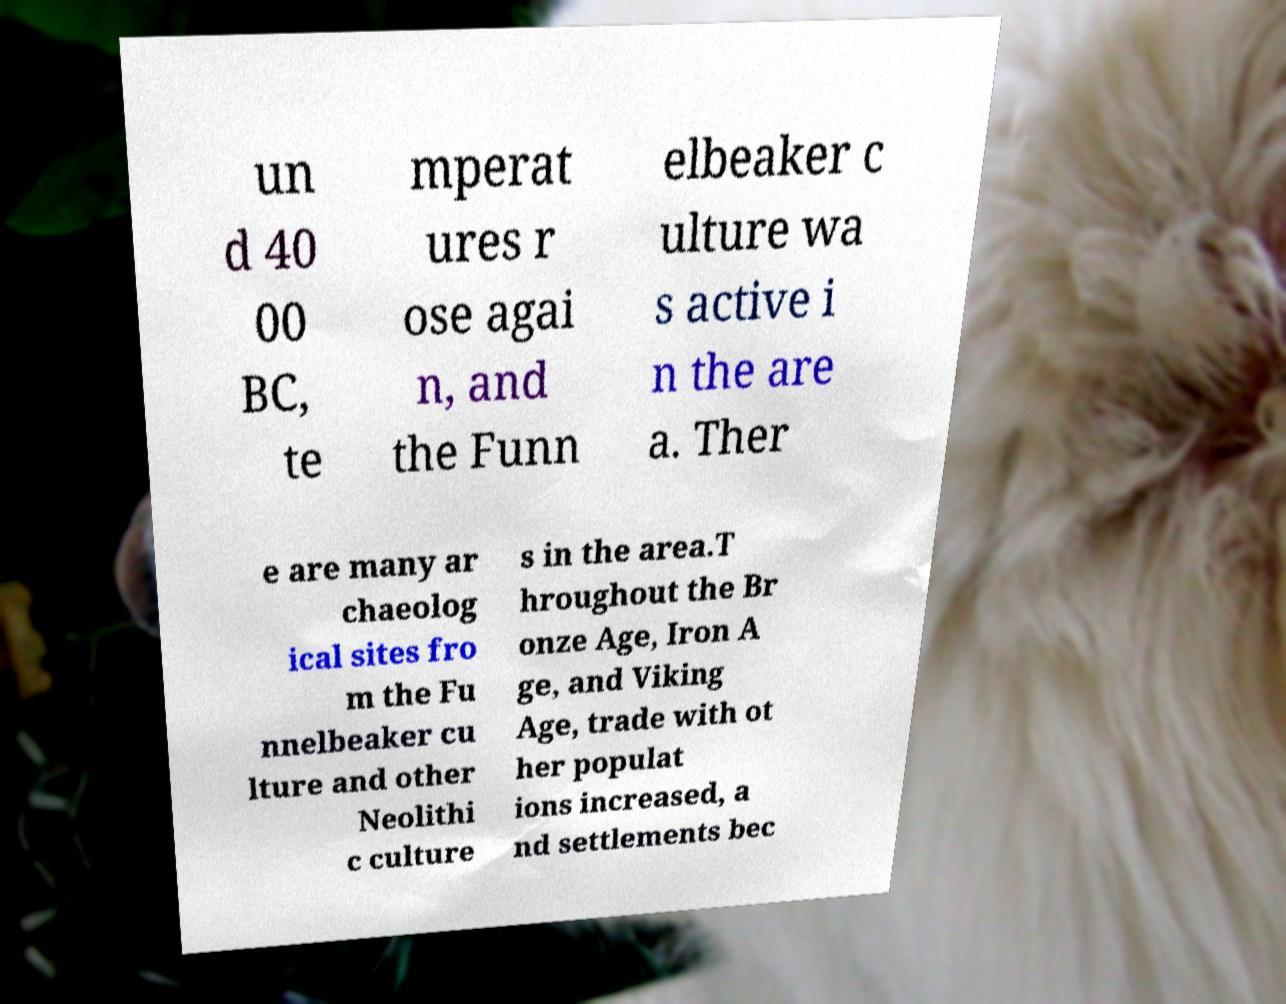For documentation purposes, I need the text within this image transcribed. Could you provide that? un d 40 00 BC, te mperat ures r ose agai n, and the Funn elbeaker c ulture wa s active i n the are a. Ther e are many ar chaeolog ical sites fro m the Fu nnelbeaker cu lture and other Neolithi c culture s in the area.T hroughout the Br onze Age, Iron A ge, and Viking Age, trade with ot her populat ions increased, a nd settlements bec 